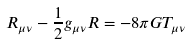Convert formula to latex. <formula><loc_0><loc_0><loc_500><loc_500>R _ { \mu \nu } - \frac { 1 } { 2 } g _ { \mu \nu } R = - 8 \pi G T _ { \mu \nu }</formula> 